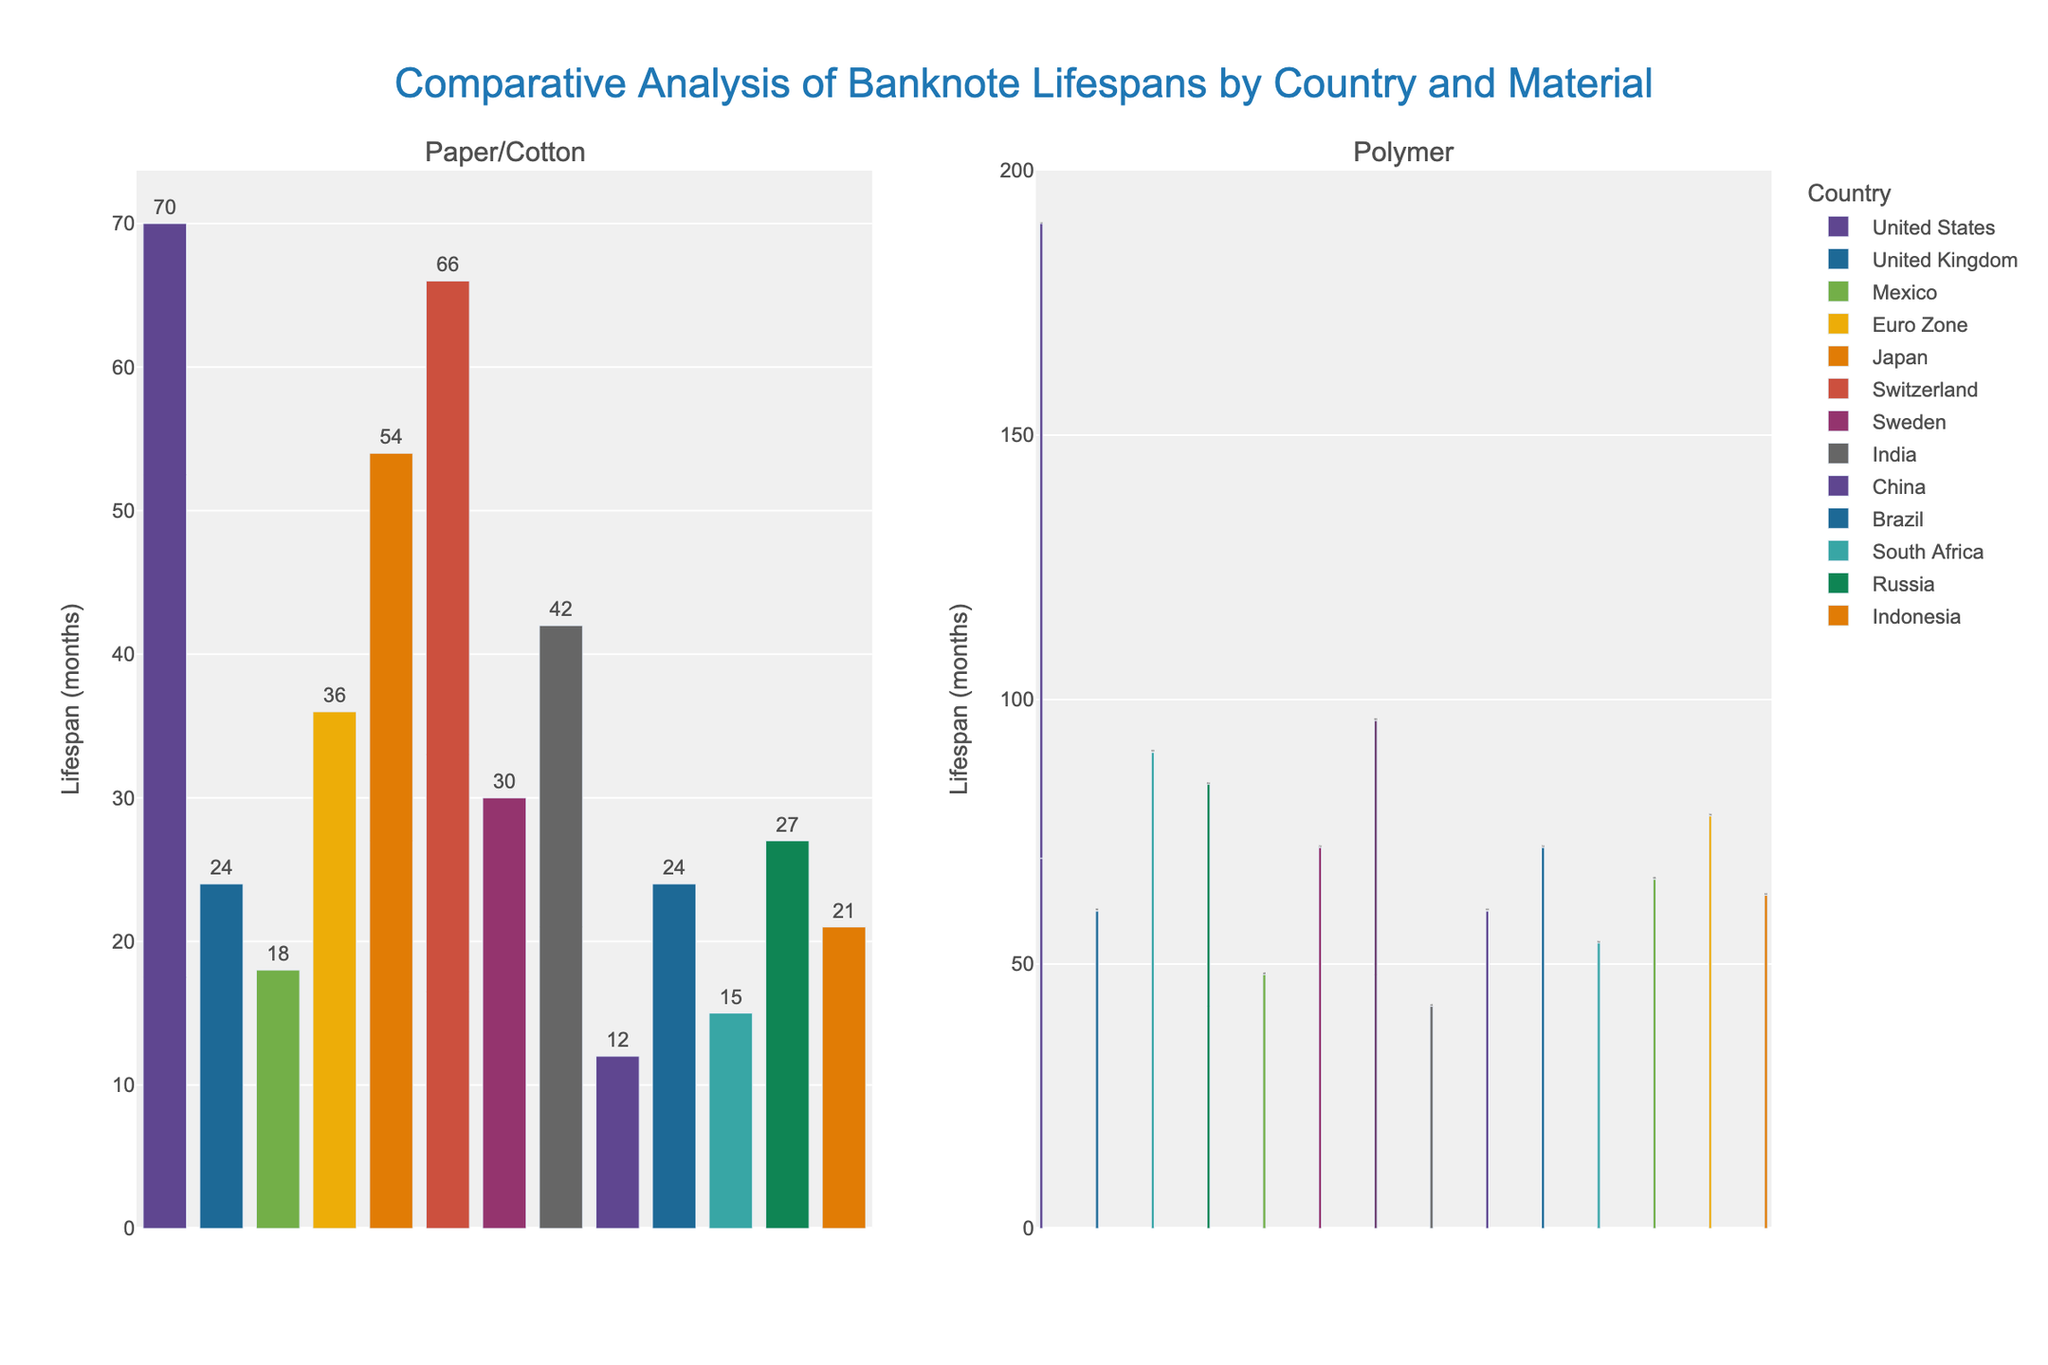What's the average lifespan of polymer banknotes in the figure? Identify the lifespans for all countries with polymer banknotes and calculate the average: (120 + 60 + 90 + 84 + 48 + 60 + 72 + 66 + 54 + 72 + 78 + 63) / 12 = 89.
Answer: 70 Which country has the longest lifespan for paper banknotes? Look for the country with the tallest bar in the "Paper/Cotton" subplot and the label "Paper". Switzerland has the longest lifespan at 66 months.
Answer: Switzerland What is the difference in lifespan between polymer and paper banknotes in Canada? Canada only has polymer banknotes with a lifespan of 84 months, so compare with lifespan of paper banknotes in any other country (e.g., UK's paper is 24 months): 84 - 24 = 60 months.
Answer: 60 months Are the lifespans of any paper banknotes equal to a polymer banknote in any country? Compare the lifespans of paper and polymer banknotes in each country to see if any match. Japan's paper banknotes (54 months) and South Africa's polymer banknotes (54 months) are equal.
Answer: Yes Which country has the highest difference in lifespan between its longest-lasting and shortest-lasting banknotes? Compare the difference between the longest and shortest lifespans within each country. The United States has a difference of 120 (polymer) - 70 (cotton-linen blend) = 50 months.
Answer: United States How many countries use polymer banknotes with a lifespan of more than 70 months? Find all countries with polymer banknotes and count how many have lifespans over 70: Australia (90), Canada (84), Nigeria (66), Vietnam (78), Indonesia (63), Sweden (72). Five countries exceed 70.
Answer: 5 countries Which country has the shortest lifespan of paper banknotes? Look for the country with the smallest bar in the "Paper/Cotton" subplot and the label "Paper". China has the shortest lifespan at 12 months.
Answer: China 